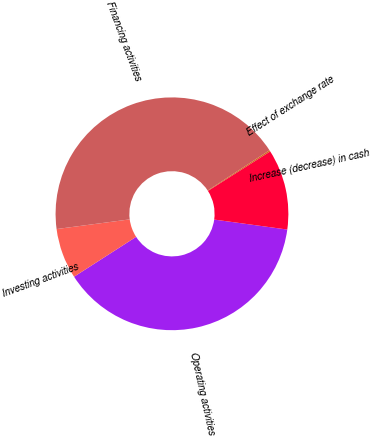Convert chart. <chart><loc_0><loc_0><loc_500><loc_500><pie_chart><fcel>Operating activities<fcel>Investing activities<fcel>Financing activities<fcel>Effect of exchange rate<fcel>Increase (decrease) in cash<nl><fcel>38.75%<fcel>7.0%<fcel>42.91%<fcel>0.19%<fcel>11.16%<nl></chart> 